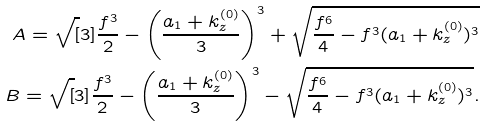Convert formula to latex. <formula><loc_0><loc_0><loc_500><loc_500>A = \sqrt { [ } 3 ] { \frac { f ^ { 3 } } { 2 } - \left ( \frac { a _ { 1 } + k _ { z } ^ { ( 0 ) } } { 3 } \right ) ^ { 3 } + \sqrt { \frac { f ^ { 6 } } { 4 } - f ^ { 3 } ( a _ { 1 } + k _ { z } ^ { ( 0 ) } ) ^ { 3 } } } \\ B = \sqrt { [ } 3 ] { \frac { f ^ { 3 } } { 2 } - \left ( \frac { a _ { 1 } + k _ { z } ^ { ( 0 ) } } { 3 } \right ) ^ { 3 } - \sqrt { \frac { f ^ { 6 } } { 4 } - f ^ { 3 } ( a _ { 1 } + k _ { z } ^ { ( 0 ) } ) ^ { 3 } } } .</formula> 